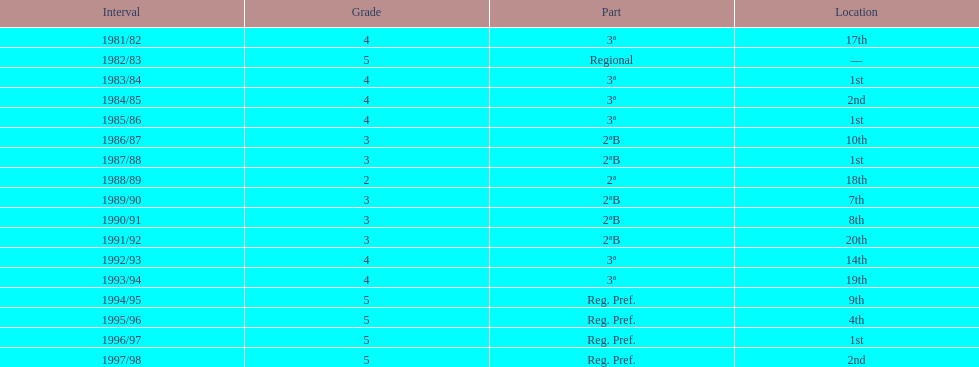How many times in total did they come in first place? 4. 